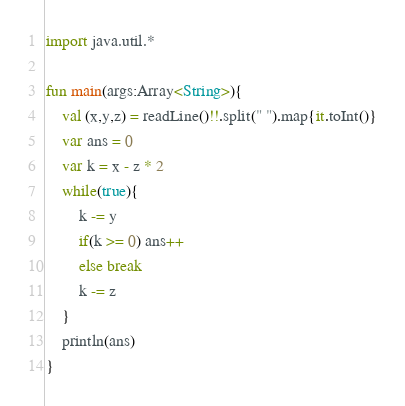Convert code to text. <code><loc_0><loc_0><loc_500><loc_500><_Kotlin_>import java.util.*

fun main(args:Array<String>){
    val (x,y,z) = readLine()!!.split(" ").map{it.toInt()}
    var ans = 0
    var k = x - z * 2
    while(true){
        k -= y
        if(k >= 0) ans++
        else break
        k -= z
    }
    println(ans)
}
</code> 